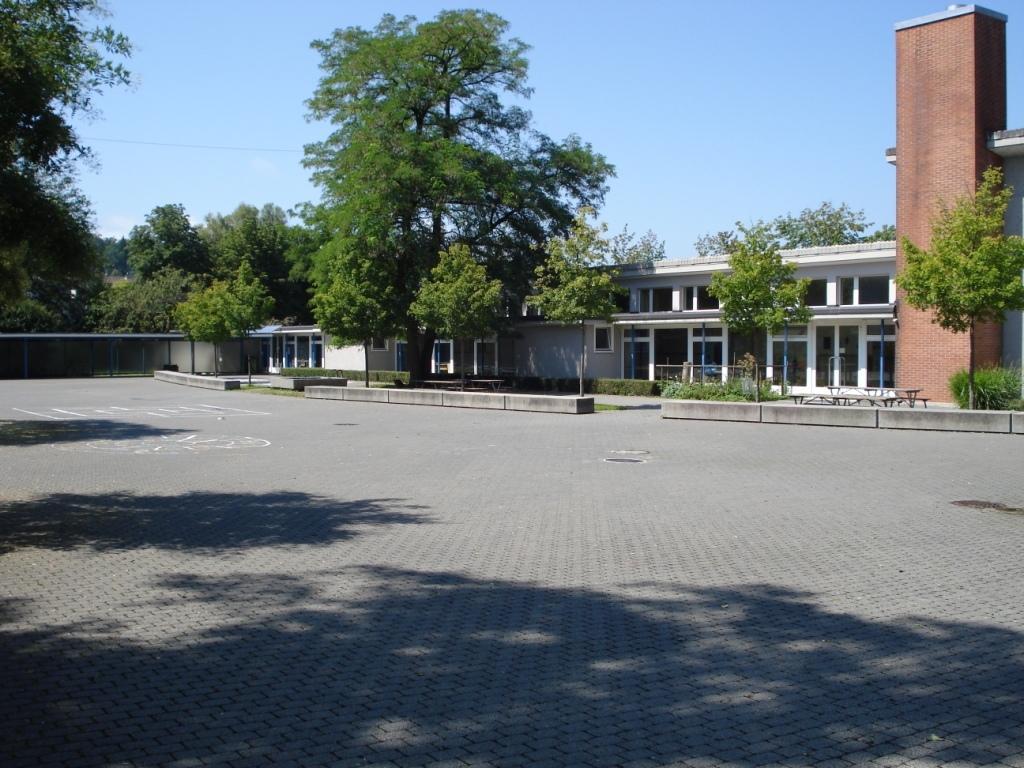In one or two sentences, can you explain what this image depicts? In the left side there are green trees and in the right side it looks like a house, at the top it is a sunny sky. 